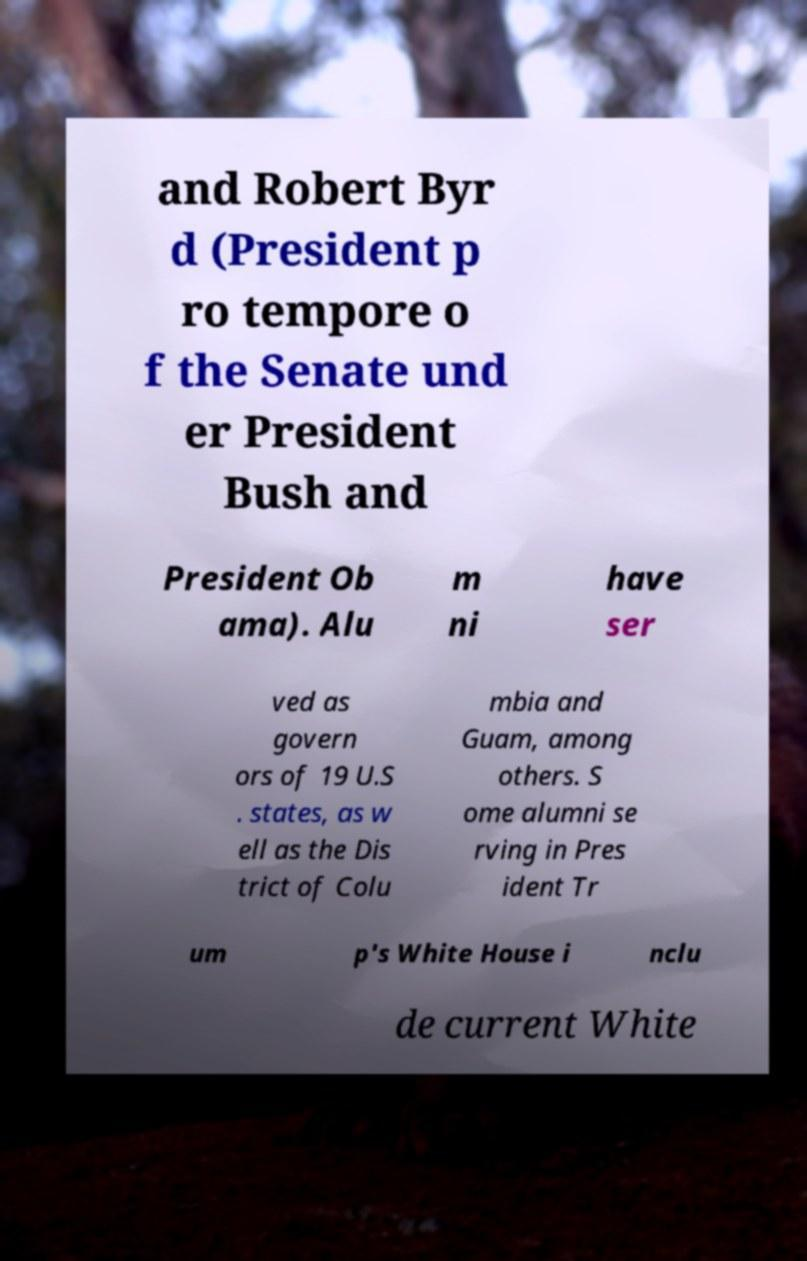Could you assist in decoding the text presented in this image and type it out clearly? and Robert Byr d (President p ro tempore o f the Senate und er President Bush and President Ob ama). Alu m ni have ser ved as govern ors of 19 U.S . states, as w ell as the Dis trict of Colu mbia and Guam, among others. S ome alumni se rving in Pres ident Tr um p's White House i nclu de current White 